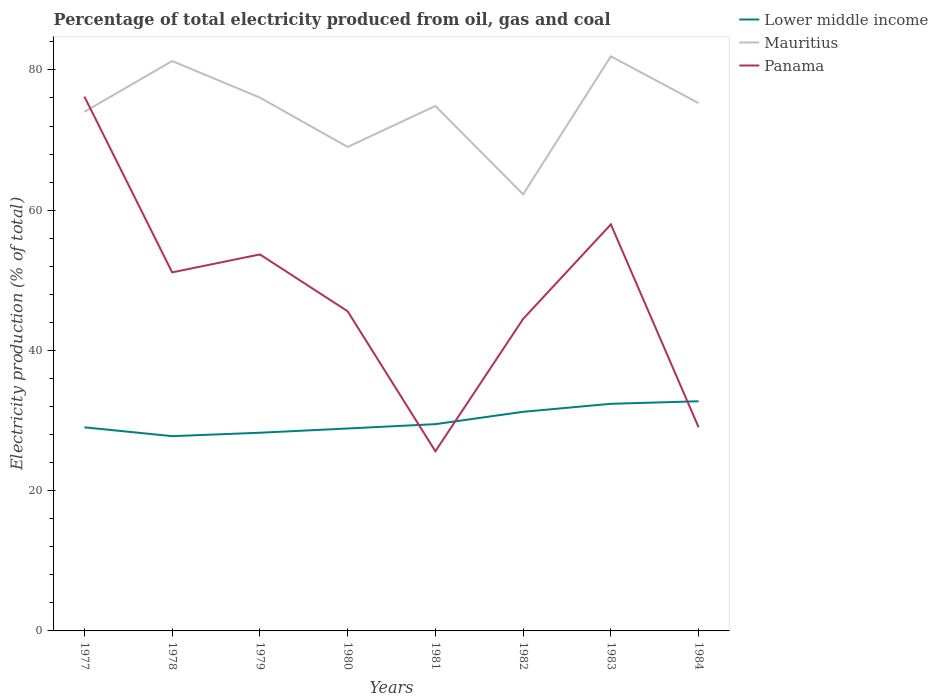Is the number of lines equal to the number of legend labels?
Give a very brief answer. Yes. Across all years, what is the maximum electricity production in in Lower middle income?
Offer a terse response. 27.78. What is the total electricity production in in Lower middle income in the graph?
Offer a terse response. -1.71. What is the difference between the highest and the second highest electricity production in in Panama?
Provide a short and direct response. 50.57. What is the difference between the highest and the lowest electricity production in in Mauritius?
Make the answer very short. 5. Is the electricity production in in Panama strictly greater than the electricity production in in Lower middle income over the years?
Offer a terse response. No. How many lines are there?
Offer a terse response. 3. How many years are there in the graph?
Keep it short and to the point. 8. What is the difference between two consecutive major ticks on the Y-axis?
Make the answer very short. 20. Are the values on the major ticks of Y-axis written in scientific E-notation?
Your answer should be compact. No. Does the graph contain any zero values?
Ensure brevity in your answer.  No. Does the graph contain grids?
Your answer should be very brief. No. How many legend labels are there?
Your response must be concise. 3. What is the title of the graph?
Offer a terse response. Percentage of total electricity produced from oil, gas and coal. What is the label or title of the Y-axis?
Make the answer very short. Electricity production (% of total). What is the Electricity production (% of total) of Lower middle income in 1977?
Provide a short and direct response. 29.03. What is the Electricity production (% of total) of Mauritius in 1977?
Provide a succinct answer. 74.03. What is the Electricity production (% of total) of Panama in 1977?
Keep it short and to the point. 76.19. What is the Electricity production (% of total) in Lower middle income in 1978?
Ensure brevity in your answer.  27.78. What is the Electricity production (% of total) in Mauritius in 1978?
Provide a succinct answer. 81.27. What is the Electricity production (% of total) in Panama in 1978?
Keep it short and to the point. 51.13. What is the Electricity production (% of total) of Lower middle income in 1979?
Keep it short and to the point. 28.26. What is the Electricity production (% of total) of Mauritius in 1979?
Your answer should be very brief. 76.06. What is the Electricity production (% of total) in Panama in 1979?
Make the answer very short. 53.69. What is the Electricity production (% of total) of Lower middle income in 1980?
Your answer should be very brief. 28.87. What is the Electricity production (% of total) of Mauritius in 1980?
Give a very brief answer. 69.01. What is the Electricity production (% of total) in Panama in 1980?
Provide a short and direct response. 45.58. What is the Electricity production (% of total) of Lower middle income in 1981?
Provide a short and direct response. 29.49. What is the Electricity production (% of total) of Mauritius in 1981?
Your answer should be compact. 74.86. What is the Electricity production (% of total) of Panama in 1981?
Provide a succinct answer. 25.62. What is the Electricity production (% of total) of Lower middle income in 1982?
Offer a terse response. 31.25. What is the Electricity production (% of total) of Mauritius in 1982?
Ensure brevity in your answer.  62.26. What is the Electricity production (% of total) in Panama in 1982?
Give a very brief answer. 44.49. What is the Electricity production (% of total) in Lower middle income in 1983?
Keep it short and to the point. 32.39. What is the Electricity production (% of total) of Mauritius in 1983?
Give a very brief answer. 81.94. What is the Electricity production (% of total) of Panama in 1983?
Provide a succinct answer. 57.97. What is the Electricity production (% of total) of Lower middle income in 1984?
Offer a very short reply. 32.75. What is the Electricity production (% of total) of Mauritius in 1984?
Give a very brief answer. 75.26. What is the Electricity production (% of total) in Panama in 1984?
Make the answer very short. 29.04. Across all years, what is the maximum Electricity production (% of total) of Lower middle income?
Give a very brief answer. 32.75. Across all years, what is the maximum Electricity production (% of total) of Mauritius?
Your answer should be compact. 81.94. Across all years, what is the maximum Electricity production (% of total) of Panama?
Provide a succinct answer. 76.19. Across all years, what is the minimum Electricity production (% of total) in Lower middle income?
Offer a terse response. 27.78. Across all years, what is the minimum Electricity production (% of total) of Mauritius?
Offer a terse response. 62.26. Across all years, what is the minimum Electricity production (% of total) in Panama?
Ensure brevity in your answer.  25.62. What is the total Electricity production (% of total) in Lower middle income in the graph?
Your response must be concise. 239.81. What is the total Electricity production (% of total) of Mauritius in the graph?
Keep it short and to the point. 594.69. What is the total Electricity production (% of total) of Panama in the graph?
Offer a very short reply. 383.72. What is the difference between the Electricity production (% of total) of Lower middle income in 1977 and that in 1978?
Your response must be concise. 1.26. What is the difference between the Electricity production (% of total) of Mauritius in 1977 and that in 1978?
Keep it short and to the point. -7.24. What is the difference between the Electricity production (% of total) in Panama in 1977 and that in 1978?
Give a very brief answer. 25.06. What is the difference between the Electricity production (% of total) of Lower middle income in 1977 and that in 1979?
Your answer should be compact. 0.77. What is the difference between the Electricity production (% of total) in Mauritius in 1977 and that in 1979?
Give a very brief answer. -2.03. What is the difference between the Electricity production (% of total) of Panama in 1977 and that in 1979?
Provide a succinct answer. 22.5. What is the difference between the Electricity production (% of total) of Lower middle income in 1977 and that in 1980?
Your response must be concise. 0.17. What is the difference between the Electricity production (% of total) in Mauritius in 1977 and that in 1980?
Your answer should be very brief. 5.01. What is the difference between the Electricity production (% of total) of Panama in 1977 and that in 1980?
Make the answer very short. 30.61. What is the difference between the Electricity production (% of total) of Lower middle income in 1977 and that in 1981?
Offer a very short reply. -0.45. What is the difference between the Electricity production (% of total) of Mauritius in 1977 and that in 1981?
Provide a succinct answer. -0.84. What is the difference between the Electricity production (% of total) of Panama in 1977 and that in 1981?
Make the answer very short. 50.57. What is the difference between the Electricity production (% of total) in Lower middle income in 1977 and that in 1982?
Provide a succinct answer. -2.21. What is the difference between the Electricity production (% of total) in Mauritius in 1977 and that in 1982?
Your answer should be very brief. 11.77. What is the difference between the Electricity production (% of total) of Panama in 1977 and that in 1982?
Give a very brief answer. 31.7. What is the difference between the Electricity production (% of total) in Lower middle income in 1977 and that in 1983?
Make the answer very short. -3.35. What is the difference between the Electricity production (% of total) of Mauritius in 1977 and that in 1983?
Provide a short and direct response. -7.91. What is the difference between the Electricity production (% of total) in Panama in 1977 and that in 1983?
Offer a very short reply. 18.22. What is the difference between the Electricity production (% of total) in Lower middle income in 1977 and that in 1984?
Keep it short and to the point. -3.72. What is the difference between the Electricity production (% of total) of Mauritius in 1977 and that in 1984?
Offer a terse response. -1.24. What is the difference between the Electricity production (% of total) of Panama in 1977 and that in 1984?
Your response must be concise. 47.16. What is the difference between the Electricity production (% of total) of Lower middle income in 1978 and that in 1979?
Your response must be concise. -0.49. What is the difference between the Electricity production (% of total) of Mauritius in 1978 and that in 1979?
Your answer should be compact. 5.21. What is the difference between the Electricity production (% of total) in Panama in 1978 and that in 1979?
Your answer should be compact. -2.56. What is the difference between the Electricity production (% of total) of Lower middle income in 1978 and that in 1980?
Your answer should be compact. -1.09. What is the difference between the Electricity production (% of total) of Mauritius in 1978 and that in 1980?
Give a very brief answer. 12.26. What is the difference between the Electricity production (% of total) of Panama in 1978 and that in 1980?
Make the answer very short. 5.55. What is the difference between the Electricity production (% of total) in Lower middle income in 1978 and that in 1981?
Your answer should be compact. -1.71. What is the difference between the Electricity production (% of total) in Mauritius in 1978 and that in 1981?
Make the answer very short. 6.41. What is the difference between the Electricity production (% of total) of Panama in 1978 and that in 1981?
Ensure brevity in your answer.  25.51. What is the difference between the Electricity production (% of total) of Lower middle income in 1978 and that in 1982?
Your response must be concise. -3.47. What is the difference between the Electricity production (% of total) in Mauritius in 1978 and that in 1982?
Your answer should be compact. 19.01. What is the difference between the Electricity production (% of total) in Panama in 1978 and that in 1982?
Keep it short and to the point. 6.64. What is the difference between the Electricity production (% of total) in Lower middle income in 1978 and that in 1983?
Make the answer very short. -4.61. What is the difference between the Electricity production (% of total) of Mauritius in 1978 and that in 1983?
Your answer should be compact. -0.67. What is the difference between the Electricity production (% of total) of Panama in 1978 and that in 1983?
Provide a succinct answer. -6.84. What is the difference between the Electricity production (% of total) in Lower middle income in 1978 and that in 1984?
Your answer should be compact. -4.97. What is the difference between the Electricity production (% of total) of Mauritius in 1978 and that in 1984?
Your response must be concise. 6.01. What is the difference between the Electricity production (% of total) of Panama in 1978 and that in 1984?
Your response must be concise. 22.1. What is the difference between the Electricity production (% of total) of Lower middle income in 1979 and that in 1980?
Offer a very short reply. -0.6. What is the difference between the Electricity production (% of total) in Mauritius in 1979 and that in 1980?
Keep it short and to the point. 7.04. What is the difference between the Electricity production (% of total) of Panama in 1979 and that in 1980?
Give a very brief answer. 8.11. What is the difference between the Electricity production (% of total) in Lower middle income in 1979 and that in 1981?
Offer a very short reply. -1.22. What is the difference between the Electricity production (% of total) of Mauritius in 1979 and that in 1981?
Offer a terse response. 1.19. What is the difference between the Electricity production (% of total) in Panama in 1979 and that in 1981?
Provide a succinct answer. 28.07. What is the difference between the Electricity production (% of total) in Lower middle income in 1979 and that in 1982?
Give a very brief answer. -2.98. What is the difference between the Electricity production (% of total) in Mauritius in 1979 and that in 1982?
Your answer should be compact. 13.8. What is the difference between the Electricity production (% of total) in Panama in 1979 and that in 1982?
Offer a terse response. 9.2. What is the difference between the Electricity production (% of total) of Lower middle income in 1979 and that in 1983?
Keep it short and to the point. -4.12. What is the difference between the Electricity production (% of total) of Mauritius in 1979 and that in 1983?
Offer a terse response. -5.88. What is the difference between the Electricity production (% of total) of Panama in 1979 and that in 1983?
Make the answer very short. -4.28. What is the difference between the Electricity production (% of total) of Lower middle income in 1979 and that in 1984?
Keep it short and to the point. -4.49. What is the difference between the Electricity production (% of total) in Mauritius in 1979 and that in 1984?
Your answer should be compact. 0.79. What is the difference between the Electricity production (% of total) of Panama in 1979 and that in 1984?
Keep it short and to the point. 24.65. What is the difference between the Electricity production (% of total) of Lower middle income in 1980 and that in 1981?
Make the answer very short. -0.62. What is the difference between the Electricity production (% of total) of Mauritius in 1980 and that in 1981?
Your answer should be compact. -5.85. What is the difference between the Electricity production (% of total) in Panama in 1980 and that in 1981?
Give a very brief answer. 19.97. What is the difference between the Electricity production (% of total) in Lower middle income in 1980 and that in 1982?
Keep it short and to the point. -2.38. What is the difference between the Electricity production (% of total) of Mauritius in 1980 and that in 1982?
Your answer should be compact. 6.76. What is the difference between the Electricity production (% of total) in Panama in 1980 and that in 1982?
Ensure brevity in your answer.  1.09. What is the difference between the Electricity production (% of total) in Lower middle income in 1980 and that in 1983?
Make the answer very short. -3.52. What is the difference between the Electricity production (% of total) in Mauritius in 1980 and that in 1983?
Your answer should be compact. -12.93. What is the difference between the Electricity production (% of total) of Panama in 1980 and that in 1983?
Your response must be concise. -12.39. What is the difference between the Electricity production (% of total) of Lower middle income in 1980 and that in 1984?
Make the answer very short. -3.88. What is the difference between the Electricity production (% of total) in Mauritius in 1980 and that in 1984?
Ensure brevity in your answer.  -6.25. What is the difference between the Electricity production (% of total) of Panama in 1980 and that in 1984?
Make the answer very short. 16.55. What is the difference between the Electricity production (% of total) in Lower middle income in 1981 and that in 1982?
Offer a terse response. -1.76. What is the difference between the Electricity production (% of total) of Mauritius in 1981 and that in 1982?
Provide a succinct answer. 12.6. What is the difference between the Electricity production (% of total) of Panama in 1981 and that in 1982?
Provide a short and direct response. -18.87. What is the difference between the Electricity production (% of total) in Lower middle income in 1981 and that in 1983?
Provide a succinct answer. -2.9. What is the difference between the Electricity production (% of total) of Mauritius in 1981 and that in 1983?
Your response must be concise. -7.08. What is the difference between the Electricity production (% of total) in Panama in 1981 and that in 1983?
Give a very brief answer. -32.35. What is the difference between the Electricity production (% of total) of Lower middle income in 1981 and that in 1984?
Keep it short and to the point. -3.26. What is the difference between the Electricity production (% of total) in Mauritius in 1981 and that in 1984?
Ensure brevity in your answer.  -0.4. What is the difference between the Electricity production (% of total) of Panama in 1981 and that in 1984?
Give a very brief answer. -3.42. What is the difference between the Electricity production (% of total) in Lower middle income in 1982 and that in 1983?
Keep it short and to the point. -1.14. What is the difference between the Electricity production (% of total) of Mauritius in 1982 and that in 1983?
Your response must be concise. -19.68. What is the difference between the Electricity production (% of total) in Panama in 1982 and that in 1983?
Make the answer very short. -13.48. What is the difference between the Electricity production (% of total) in Lower middle income in 1982 and that in 1984?
Provide a short and direct response. -1.5. What is the difference between the Electricity production (% of total) of Mauritius in 1982 and that in 1984?
Make the answer very short. -13. What is the difference between the Electricity production (% of total) in Panama in 1982 and that in 1984?
Your answer should be very brief. 15.46. What is the difference between the Electricity production (% of total) in Lower middle income in 1983 and that in 1984?
Your answer should be very brief. -0.36. What is the difference between the Electricity production (% of total) of Mauritius in 1983 and that in 1984?
Offer a terse response. 6.68. What is the difference between the Electricity production (% of total) of Panama in 1983 and that in 1984?
Your answer should be compact. 28.94. What is the difference between the Electricity production (% of total) in Lower middle income in 1977 and the Electricity production (% of total) in Mauritius in 1978?
Make the answer very short. -52.24. What is the difference between the Electricity production (% of total) of Lower middle income in 1977 and the Electricity production (% of total) of Panama in 1978?
Your answer should be very brief. -22.1. What is the difference between the Electricity production (% of total) of Mauritius in 1977 and the Electricity production (% of total) of Panama in 1978?
Ensure brevity in your answer.  22.89. What is the difference between the Electricity production (% of total) in Lower middle income in 1977 and the Electricity production (% of total) in Mauritius in 1979?
Make the answer very short. -47.02. What is the difference between the Electricity production (% of total) of Lower middle income in 1977 and the Electricity production (% of total) of Panama in 1979?
Your answer should be very brief. -24.66. What is the difference between the Electricity production (% of total) of Mauritius in 1977 and the Electricity production (% of total) of Panama in 1979?
Your answer should be compact. 20.34. What is the difference between the Electricity production (% of total) in Lower middle income in 1977 and the Electricity production (% of total) in Mauritius in 1980?
Give a very brief answer. -39.98. What is the difference between the Electricity production (% of total) of Lower middle income in 1977 and the Electricity production (% of total) of Panama in 1980?
Make the answer very short. -16.55. What is the difference between the Electricity production (% of total) of Mauritius in 1977 and the Electricity production (% of total) of Panama in 1980?
Your answer should be very brief. 28.44. What is the difference between the Electricity production (% of total) in Lower middle income in 1977 and the Electricity production (% of total) in Mauritius in 1981?
Your answer should be compact. -45.83. What is the difference between the Electricity production (% of total) in Lower middle income in 1977 and the Electricity production (% of total) in Panama in 1981?
Provide a succinct answer. 3.41. What is the difference between the Electricity production (% of total) in Mauritius in 1977 and the Electricity production (% of total) in Panama in 1981?
Make the answer very short. 48.41. What is the difference between the Electricity production (% of total) in Lower middle income in 1977 and the Electricity production (% of total) in Mauritius in 1982?
Ensure brevity in your answer.  -33.23. What is the difference between the Electricity production (% of total) of Lower middle income in 1977 and the Electricity production (% of total) of Panama in 1982?
Provide a succinct answer. -15.46. What is the difference between the Electricity production (% of total) of Mauritius in 1977 and the Electricity production (% of total) of Panama in 1982?
Offer a terse response. 29.53. What is the difference between the Electricity production (% of total) of Lower middle income in 1977 and the Electricity production (% of total) of Mauritius in 1983?
Give a very brief answer. -52.91. What is the difference between the Electricity production (% of total) in Lower middle income in 1977 and the Electricity production (% of total) in Panama in 1983?
Provide a succinct answer. -28.94. What is the difference between the Electricity production (% of total) of Mauritius in 1977 and the Electricity production (% of total) of Panama in 1983?
Your answer should be very brief. 16.05. What is the difference between the Electricity production (% of total) of Lower middle income in 1977 and the Electricity production (% of total) of Mauritius in 1984?
Your answer should be very brief. -46.23. What is the difference between the Electricity production (% of total) in Lower middle income in 1977 and the Electricity production (% of total) in Panama in 1984?
Provide a short and direct response. -0. What is the difference between the Electricity production (% of total) in Mauritius in 1977 and the Electricity production (% of total) in Panama in 1984?
Your answer should be very brief. 44.99. What is the difference between the Electricity production (% of total) of Lower middle income in 1978 and the Electricity production (% of total) of Mauritius in 1979?
Ensure brevity in your answer.  -48.28. What is the difference between the Electricity production (% of total) of Lower middle income in 1978 and the Electricity production (% of total) of Panama in 1979?
Your answer should be very brief. -25.91. What is the difference between the Electricity production (% of total) of Mauritius in 1978 and the Electricity production (% of total) of Panama in 1979?
Give a very brief answer. 27.58. What is the difference between the Electricity production (% of total) of Lower middle income in 1978 and the Electricity production (% of total) of Mauritius in 1980?
Ensure brevity in your answer.  -41.24. What is the difference between the Electricity production (% of total) of Lower middle income in 1978 and the Electricity production (% of total) of Panama in 1980?
Offer a very short reply. -17.81. What is the difference between the Electricity production (% of total) of Mauritius in 1978 and the Electricity production (% of total) of Panama in 1980?
Offer a very short reply. 35.68. What is the difference between the Electricity production (% of total) of Lower middle income in 1978 and the Electricity production (% of total) of Mauritius in 1981?
Provide a succinct answer. -47.09. What is the difference between the Electricity production (% of total) in Lower middle income in 1978 and the Electricity production (% of total) in Panama in 1981?
Your response must be concise. 2.16. What is the difference between the Electricity production (% of total) of Mauritius in 1978 and the Electricity production (% of total) of Panama in 1981?
Your answer should be very brief. 55.65. What is the difference between the Electricity production (% of total) of Lower middle income in 1978 and the Electricity production (% of total) of Mauritius in 1982?
Ensure brevity in your answer.  -34.48. What is the difference between the Electricity production (% of total) of Lower middle income in 1978 and the Electricity production (% of total) of Panama in 1982?
Provide a succinct answer. -16.72. What is the difference between the Electricity production (% of total) in Mauritius in 1978 and the Electricity production (% of total) in Panama in 1982?
Make the answer very short. 36.78. What is the difference between the Electricity production (% of total) of Lower middle income in 1978 and the Electricity production (% of total) of Mauritius in 1983?
Provide a short and direct response. -54.17. What is the difference between the Electricity production (% of total) of Lower middle income in 1978 and the Electricity production (% of total) of Panama in 1983?
Your answer should be very brief. -30.2. What is the difference between the Electricity production (% of total) in Mauritius in 1978 and the Electricity production (% of total) in Panama in 1983?
Provide a short and direct response. 23.3. What is the difference between the Electricity production (% of total) of Lower middle income in 1978 and the Electricity production (% of total) of Mauritius in 1984?
Keep it short and to the point. -47.49. What is the difference between the Electricity production (% of total) of Lower middle income in 1978 and the Electricity production (% of total) of Panama in 1984?
Give a very brief answer. -1.26. What is the difference between the Electricity production (% of total) in Mauritius in 1978 and the Electricity production (% of total) in Panama in 1984?
Keep it short and to the point. 52.23. What is the difference between the Electricity production (% of total) of Lower middle income in 1979 and the Electricity production (% of total) of Mauritius in 1980?
Offer a very short reply. -40.75. What is the difference between the Electricity production (% of total) in Lower middle income in 1979 and the Electricity production (% of total) in Panama in 1980?
Ensure brevity in your answer.  -17.32. What is the difference between the Electricity production (% of total) of Mauritius in 1979 and the Electricity production (% of total) of Panama in 1980?
Provide a short and direct response. 30.47. What is the difference between the Electricity production (% of total) of Lower middle income in 1979 and the Electricity production (% of total) of Mauritius in 1981?
Your answer should be very brief. -46.6. What is the difference between the Electricity production (% of total) in Lower middle income in 1979 and the Electricity production (% of total) in Panama in 1981?
Offer a very short reply. 2.64. What is the difference between the Electricity production (% of total) in Mauritius in 1979 and the Electricity production (% of total) in Panama in 1981?
Offer a very short reply. 50.44. What is the difference between the Electricity production (% of total) in Lower middle income in 1979 and the Electricity production (% of total) in Mauritius in 1982?
Offer a terse response. -34. What is the difference between the Electricity production (% of total) in Lower middle income in 1979 and the Electricity production (% of total) in Panama in 1982?
Offer a very short reply. -16.23. What is the difference between the Electricity production (% of total) in Mauritius in 1979 and the Electricity production (% of total) in Panama in 1982?
Give a very brief answer. 31.56. What is the difference between the Electricity production (% of total) of Lower middle income in 1979 and the Electricity production (% of total) of Mauritius in 1983?
Provide a short and direct response. -53.68. What is the difference between the Electricity production (% of total) of Lower middle income in 1979 and the Electricity production (% of total) of Panama in 1983?
Provide a succinct answer. -29.71. What is the difference between the Electricity production (% of total) of Mauritius in 1979 and the Electricity production (% of total) of Panama in 1983?
Your answer should be compact. 18.08. What is the difference between the Electricity production (% of total) in Lower middle income in 1979 and the Electricity production (% of total) in Mauritius in 1984?
Your answer should be compact. -47. What is the difference between the Electricity production (% of total) in Lower middle income in 1979 and the Electricity production (% of total) in Panama in 1984?
Your answer should be compact. -0.77. What is the difference between the Electricity production (% of total) of Mauritius in 1979 and the Electricity production (% of total) of Panama in 1984?
Provide a short and direct response. 47.02. What is the difference between the Electricity production (% of total) of Lower middle income in 1980 and the Electricity production (% of total) of Mauritius in 1981?
Offer a terse response. -45.99. What is the difference between the Electricity production (% of total) of Lower middle income in 1980 and the Electricity production (% of total) of Panama in 1981?
Give a very brief answer. 3.25. What is the difference between the Electricity production (% of total) in Mauritius in 1980 and the Electricity production (% of total) in Panama in 1981?
Your answer should be very brief. 43.39. What is the difference between the Electricity production (% of total) of Lower middle income in 1980 and the Electricity production (% of total) of Mauritius in 1982?
Make the answer very short. -33.39. What is the difference between the Electricity production (% of total) in Lower middle income in 1980 and the Electricity production (% of total) in Panama in 1982?
Offer a terse response. -15.62. What is the difference between the Electricity production (% of total) of Mauritius in 1980 and the Electricity production (% of total) of Panama in 1982?
Your answer should be very brief. 24.52. What is the difference between the Electricity production (% of total) in Lower middle income in 1980 and the Electricity production (% of total) in Mauritius in 1983?
Give a very brief answer. -53.07. What is the difference between the Electricity production (% of total) in Lower middle income in 1980 and the Electricity production (% of total) in Panama in 1983?
Ensure brevity in your answer.  -29.11. What is the difference between the Electricity production (% of total) in Mauritius in 1980 and the Electricity production (% of total) in Panama in 1983?
Make the answer very short. 11.04. What is the difference between the Electricity production (% of total) of Lower middle income in 1980 and the Electricity production (% of total) of Mauritius in 1984?
Make the answer very short. -46.4. What is the difference between the Electricity production (% of total) of Lower middle income in 1980 and the Electricity production (% of total) of Panama in 1984?
Provide a short and direct response. -0.17. What is the difference between the Electricity production (% of total) of Mauritius in 1980 and the Electricity production (% of total) of Panama in 1984?
Offer a terse response. 39.98. What is the difference between the Electricity production (% of total) in Lower middle income in 1981 and the Electricity production (% of total) in Mauritius in 1982?
Keep it short and to the point. -32.77. What is the difference between the Electricity production (% of total) of Lower middle income in 1981 and the Electricity production (% of total) of Panama in 1982?
Provide a succinct answer. -15.01. What is the difference between the Electricity production (% of total) in Mauritius in 1981 and the Electricity production (% of total) in Panama in 1982?
Offer a very short reply. 30.37. What is the difference between the Electricity production (% of total) in Lower middle income in 1981 and the Electricity production (% of total) in Mauritius in 1983?
Offer a very short reply. -52.45. What is the difference between the Electricity production (% of total) of Lower middle income in 1981 and the Electricity production (% of total) of Panama in 1983?
Make the answer very short. -28.49. What is the difference between the Electricity production (% of total) in Mauritius in 1981 and the Electricity production (% of total) in Panama in 1983?
Provide a short and direct response. 16.89. What is the difference between the Electricity production (% of total) in Lower middle income in 1981 and the Electricity production (% of total) in Mauritius in 1984?
Make the answer very short. -45.78. What is the difference between the Electricity production (% of total) of Lower middle income in 1981 and the Electricity production (% of total) of Panama in 1984?
Your answer should be very brief. 0.45. What is the difference between the Electricity production (% of total) of Mauritius in 1981 and the Electricity production (% of total) of Panama in 1984?
Your answer should be compact. 45.83. What is the difference between the Electricity production (% of total) of Lower middle income in 1982 and the Electricity production (% of total) of Mauritius in 1983?
Your answer should be compact. -50.69. What is the difference between the Electricity production (% of total) in Lower middle income in 1982 and the Electricity production (% of total) in Panama in 1983?
Your answer should be compact. -26.73. What is the difference between the Electricity production (% of total) in Mauritius in 1982 and the Electricity production (% of total) in Panama in 1983?
Offer a very short reply. 4.29. What is the difference between the Electricity production (% of total) of Lower middle income in 1982 and the Electricity production (% of total) of Mauritius in 1984?
Provide a succinct answer. -44.02. What is the difference between the Electricity production (% of total) in Lower middle income in 1982 and the Electricity production (% of total) in Panama in 1984?
Keep it short and to the point. 2.21. What is the difference between the Electricity production (% of total) of Mauritius in 1982 and the Electricity production (% of total) of Panama in 1984?
Provide a short and direct response. 33.22. What is the difference between the Electricity production (% of total) in Lower middle income in 1983 and the Electricity production (% of total) in Mauritius in 1984?
Ensure brevity in your answer.  -42.88. What is the difference between the Electricity production (% of total) of Lower middle income in 1983 and the Electricity production (% of total) of Panama in 1984?
Your answer should be compact. 3.35. What is the difference between the Electricity production (% of total) of Mauritius in 1983 and the Electricity production (% of total) of Panama in 1984?
Your answer should be very brief. 52.9. What is the average Electricity production (% of total) of Lower middle income per year?
Provide a short and direct response. 29.98. What is the average Electricity production (% of total) in Mauritius per year?
Offer a terse response. 74.34. What is the average Electricity production (% of total) in Panama per year?
Offer a very short reply. 47.97. In the year 1977, what is the difference between the Electricity production (% of total) of Lower middle income and Electricity production (% of total) of Mauritius?
Provide a short and direct response. -44.99. In the year 1977, what is the difference between the Electricity production (% of total) of Lower middle income and Electricity production (% of total) of Panama?
Offer a terse response. -47.16. In the year 1977, what is the difference between the Electricity production (% of total) of Mauritius and Electricity production (% of total) of Panama?
Your answer should be very brief. -2.17. In the year 1978, what is the difference between the Electricity production (% of total) in Lower middle income and Electricity production (% of total) in Mauritius?
Your response must be concise. -53.49. In the year 1978, what is the difference between the Electricity production (% of total) of Lower middle income and Electricity production (% of total) of Panama?
Your answer should be very brief. -23.36. In the year 1978, what is the difference between the Electricity production (% of total) in Mauritius and Electricity production (% of total) in Panama?
Your answer should be very brief. 30.14. In the year 1979, what is the difference between the Electricity production (% of total) of Lower middle income and Electricity production (% of total) of Mauritius?
Make the answer very short. -47.79. In the year 1979, what is the difference between the Electricity production (% of total) in Lower middle income and Electricity production (% of total) in Panama?
Make the answer very short. -25.43. In the year 1979, what is the difference between the Electricity production (% of total) of Mauritius and Electricity production (% of total) of Panama?
Offer a terse response. 22.37. In the year 1980, what is the difference between the Electricity production (% of total) of Lower middle income and Electricity production (% of total) of Mauritius?
Your response must be concise. -40.15. In the year 1980, what is the difference between the Electricity production (% of total) in Lower middle income and Electricity production (% of total) in Panama?
Provide a short and direct response. -16.72. In the year 1980, what is the difference between the Electricity production (% of total) of Mauritius and Electricity production (% of total) of Panama?
Make the answer very short. 23.43. In the year 1981, what is the difference between the Electricity production (% of total) of Lower middle income and Electricity production (% of total) of Mauritius?
Keep it short and to the point. -45.38. In the year 1981, what is the difference between the Electricity production (% of total) of Lower middle income and Electricity production (% of total) of Panama?
Keep it short and to the point. 3.87. In the year 1981, what is the difference between the Electricity production (% of total) in Mauritius and Electricity production (% of total) in Panama?
Offer a very short reply. 49.24. In the year 1982, what is the difference between the Electricity production (% of total) of Lower middle income and Electricity production (% of total) of Mauritius?
Provide a succinct answer. -31.01. In the year 1982, what is the difference between the Electricity production (% of total) of Lower middle income and Electricity production (% of total) of Panama?
Your answer should be very brief. -13.25. In the year 1982, what is the difference between the Electricity production (% of total) in Mauritius and Electricity production (% of total) in Panama?
Provide a succinct answer. 17.77. In the year 1983, what is the difference between the Electricity production (% of total) of Lower middle income and Electricity production (% of total) of Mauritius?
Ensure brevity in your answer.  -49.55. In the year 1983, what is the difference between the Electricity production (% of total) in Lower middle income and Electricity production (% of total) in Panama?
Your answer should be very brief. -25.58. In the year 1983, what is the difference between the Electricity production (% of total) of Mauritius and Electricity production (% of total) of Panama?
Your answer should be very brief. 23.97. In the year 1984, what is the difference between the Electricity production (% of total) in Lower middle income and Electricity production (% of total) in Mauritius?
Your answer should be compact. -42.51. In the year 1984, what is the difference between the Electricity production (% of total) of Lower middle income and Electricity production (% of total) of Panama?
Your response must be concise. 3.71. In the year 1984, what is the difference between the Electricity production (% of total) of Mauritius and Electricity production (% of total) of Panama?
Provide a succinct answer. 46.23. What is the ratio of the Electricity production (% of total) in Lower middle income in 1977 to that in 1978?
Your answer should be very brief. 1.05. What is the ratio of the Electricity production (% of total) of Mauritius in 1977 to that in 1978?
Your answer should be very brief. 0.91. What is the ratio of the Electricity production (% of total) in Panama in 1977 to that in 1978?
Ensure brevity in your answer.  1.49. What is the ratio of the Electricity production (% of total) of Lower middle income in 1977 to that in 1979?
Offer a very short reply. 1.03. What is the ratio of the Electricity production (% of total) in Mauritius in 1977 to that in 1979?
Keep it short and to the point. 0.97. What is the ratio of the Electricity production (% of total) of Panama in 1977 to that in 1979?
Give a very brief answer. 1.42. What is the ratio of the Electricity production (% of total) of Mauritius in 1977 to that in 1980?
Your response must be concise. 1.07. What is the ratio of the Electricity production (% of total) of Panama in 1977 to that in 1980?
Your response must be concise. 1.67. What is the ratio of the Electricity production (% of total) in Lower middle income in 1977 to that in 1981?
Offer a terse response. 0.98. What is the ratio of the Electricity production (% of total) of Mauritius in 1977 to that in 1981?
Your answer should be very brief. 0.99. What is the ratio of the Electricity production (% of total) in Panama in 1977 to that in 1981?
Your answer should be very brief. 2.97. What is the ratio of the Electricity production (% of total) in Lower middle income in 1977 to that in 1982?
Your answer should be very brief. 0.93. What is the ratio of the Electricity production (% of total) of Mauritius in 1977 to that in 1982?
Make the answer very short. 1.19. What is the ratio of the Electricity production (% of total) of Panama in 1977 to that in 1982?
Provide a succinct answer. 1.71. What is the ratio of the Electricity production (% of total) of Lower middle income in 1977 to that in 1983?
Your response must be concise. 0.9. What is the ratio of the Electricity production (% of total) in Mauritius in 1977 to that in 1983?
Offer a very short reply. 0.9. What is the ratio of the Electricity production (% of total) in Panama in 1977 to that in 1983?
Offer a very short reply. 1.31. What is the ratio of the Electricity production (% of total) of Lower middle income in 1977 to that in 1984?
Give a very brief answer. 0.89. What is the ratio of the Electricity production (% of total) of Mauritius in 1977 to that in 1984?
Provide a succinct answer. 0.98. What is the ratio of the Electricity production (% of total) of Panama in 1977 to that in 1984?
Your response must be concise. 2.62. What is the ratio of the Electricity production (% of total) of Lower middle income in 1978 to that in 1979?
Give a very brief answer. 0.98. What is the ratio of the Electricity production (% of total) of Mauritius in 1978 to that in 1979?
Your response must be concise. 1.07. What is the ratio of the Electricity production (% of total) in Lower middle income in 1978 to that in 1980?
Your response must be concise. 0.96. What is the ratio of the Electricity production (% of total) in Mauritius in 1978 to that in 1980?
Ensure brevity in your answer.  1.18. What is the ratio of the Electricity production (% of total) of Panama in 1978 to that in 1980?
Offer a terse response. 1.12. What is the ratio of the Electricity production (% of total) in Lower middle income in 1978 to that in 1981?
Your answer should be compact. 0.94. What is the ratio of the Electricity production (% of total) in Mauritius in 1978 to that in 1981?
Offer a very short reply. 1.09. What is the ratio of the Electricity production (% of total) in Panama in 1978 to that in 1981?
Your answer should be very brief. 2. What is the ratio of the Electricity production (% of total) of Lower middle income in 1978 to that in 1982?
Your answer should be compact. 0.89. What is the ratio of the Electricity production (% of total) in Mauritius in 1978 to that in 1982?
Offer a terse response. 1.31. What is the ratio of the Electricity production (% of total) of Panama in 1978 to that in 1982?
Provide a succinct answer. 1.15. What is the ratio of the Electricity production (% of total) in Lower middle income in 1978 to that in 1983?
Make the answer very short. 0.86. What is the ratio of the Electricity production (% of total) in Panama in 1978 to that in 1983?
Give a very brief answer. 0.88. What is the ratio of the Electricity production (% of total) in Lower middle income in 1978 to that in 1984?
Make the answer very short. 0.85. What is the ratio of the Electricity production (% of total) in Mauritius in 1978 to that in 1984?
Provide a succinct answer. 1.08. What is the ratio of the Electricity production (% of total) in Panama in 1978 to that in 1984?
Give a very brief answer. 1.76. What is the ratio of the Electricity production (% of total) of Lower middle income in 1979 to that in 1980?
Provide a short and direct response. 0.98. What is the ratio of the Electricity production (% of total) of Mauritius in 1979 to that in 1980?
Offer a very short reply. 1.1. What is the ratio of the Electricity production (% of total) of Panama in 1979 to that in 1980?
Make the answer very short. 1.18. What is the ratio of the Electricity production (% of total) of Lower middle income in 1979 to that in 1981?
Keep it short and to the point. 0.96. What is the ratio of the Electricity production (% of total) of Mauritius in 1979 to that in 1981?
Offer a terse response. 1.02. What is the ratio of the Electricity production (% of total) in Panama in 1979 to that in 1981?
Ensure brevity in your answer.  2.1. What is the ratio of the Electricity production (% of total) in Lower middle income in 1979 to that in 1982?
Ensure brevity in your answer.  0.9. What is the ratio of the Electricity production (% of total) in Mauritius in 1979 to that in 1982?
Your answer should be very brief. 1.22. What is the ratio of the Electricity production (% of total) in Panama in 1979 to that in 1982?
Offer a very short reply. 1.21. What is the ratio of the Electricity production (% of total) of Lower middle income in 1979 to that in 1983?
Your answer should be compact. 0.87. What is the ratio of the Electricity production (% of total) in Mauritius in 1979 to that in 1983?
Give a very brief answer. 0.93. What is the ratio of the Electricity production (% of total) of Panama in 1979 to that in 1983?
Provide a short and direct response. 0.93. What is the ratio of the Electricity production (% of total) of Lower middle income in 1979 to that in 1984?
Your answer should be very brief. 0.86. What is the ratio of the Electricity production (% of total) in Mauritius in 1979 to that in 1984?
Ensure brevity in your answer.  1.01. What is the ratio of the Electricity production (% of total) in Panama in 1979 to that in 1984?
Ensure brevity in your answer.  1.85. What is the ratio of the Electricity production (% of total) of Lower middle income in 1980 to that in 1981?
Provide a short and direct response. 0.98. What is the ratio of the Electricity production (% of total) of Mauritius in 1980 to that in 1981?
Provide a succinct answer. 0.92. What is the ratio of the Electricity production (% of total) in Panama in 1980 to that in 1981?
Give a very brief answer. 1.78. What is the ratio of the Electricity production (% of total) in Lower middle income in 1980 to that in 1982?
Make the answer very short. 0.92. What is the ratio of the Electricity production (% of total) in Mauritius in 1980 to that in 1982?
Your answer should be compact. 1.11. What is the ratio of the Electricity production (% of total) in Panama in 1980 to that in 1982?
Make the answer very short. 1.02. What is the ratio of the Electricity production (% of total) of Lower middle income in 1980 to that in 1983?
Your answer should be very brief. 0.89. What is the ratio of the Electricity production (% of total) of Mauritius in 1980 to that in 1983?
Offer a terse response. 0.84. What is the ratio of the Electricity production (% of total) of Panama in 1980 to that in 1983?
Provide a short and direct response. 0.79. What is the ratio of the Electricity production (% of total) in Lower middle income in 1980 to that in 1984?
Give a very brief answer. 0.88. What is the ratio of the Electricity production (% of total) in Mauritius in 1980 to that in 1984?
Offer a very short reply. 0.92. What is the ratio of the Electricity production (% of total) of Panama in 1980 to that in 1984?
Your answer should be very brief. 1.57. What is the ratio of the Electricity production (% of total) in Lower middle income in 1981 to that in 1982?
Provide a short and direct response. 0.94. What is the ratio of the Electricity production (% of total) in Mauritius in 1981 to that in 1982?
Make the answer very short. 1.2. What is the ratio of the Electricity production (% of total) of Panama in 1981 to that in 1982?
Your answer should be compact. 0.58. What is the ratio of the Electricity production (% of total) in Lower middle income in 1981 to that in 1983?
Your answer should be very brief. 0.91. What is the ratio of the Electricity production (% of total) in Mauritius in 1981 to that in 1983?
Give a very brief answer. 0.91. What is the ratio of the Electricity production (% of total) of Panama in 1981 to that in 1983?
Your response must be concise. 0.44. What is the ratio of the Electricity production (% of total) of Lower middle income in 1981 to that in 1984?
Your answer should be very brief. 0.9. What is the ratio of the Electricity production (% of total) in Panama in 1981 to that in 1984?
Your answer should be compact. 0.88. What is the ratio of the Electricity production (% of total) in Lower middle income in 1982 to that in 1983?
Make the answer very short. 0.96. What is the ratio of the Electricity production (% of total) of Mauritius in 1982 to that in 1983?
Your answer should be very brief. 0.76. What is the ratio of the Electricity production (% of total) of Panama in 1982 to that in 1983?
Keep it short and to the point. 0.77. What is the ratio of the Electricity production (% of total) of Lower middle income in 1982 to that in 1984?
Provide a succinct answer. 0.95. What is the ratio of the Electricity production (% of total) in Mauritius in 1982 to that in 1984?
Offer a very short reply. 0.83. What is the ratio of the Electricity production (% of total) in Panama in 1982 to that in 1984?
Offer a very short reply. 1.53. What is the ratio of the Electricity production (% of total) in Lower middle income in 1983 to that in 1984?
Provide a short and direct response. 0.99. What is the ratio of the Electricity production (% of total) of Mauritius in 1983 to that in 1984?
Offer a terse response. 1.09. What is the ratio of the Electricity production (% of total) of Panama in 1983 to that in 1984?
Your response must be concise. 2. What is the difference between the highest and the second highest Electricity production (% of total) of Lower middle income?
Give a very brief answer. 0.36. What is the difference between the highest and the second highest Electricity production (% of total) of Mauritius?
Ensure brevity in your answer.  0.67. What is the difference between the highest and the second highest Electricity production (% of total) of Panama?
Offer a very short reply. 18.22. What is the difference between the highest and the lowest Electricity production (% of total) in Lower middle income?
Make the answer very short. 4.97. What is the difference between the highest and the lowest Electricity production (% of total) in Mauritius?
Provide a succinct answer. 19.68. What is the difference between the highest and the lowest Electricity production (% of total) of Panama?
Provide a succinct answer. 50.57. 